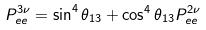Convert formula to latex. <formula><loc_0><loc_0><loc_500><loc_500>P ^ { 3 \nu } _ { e e } = \sin ^ { 4 } \theta _ { 1 3 } + \cos ^ { 4 } \theta _ { 1 3 } P ^ { 2 \nu } _ { e e }</formula> 